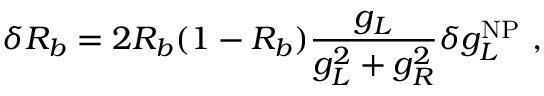<formula> <loc_0><loc_0><loc_500><loc_500>\delta R _ { b } = 2 R _ { b } ( 1 - R _ { b } ) \frac { g _ { L } } { g _ { L } ^ { 2 } + g _ { R } ^ { 2 } } \delta g _ { L } ^ { N P } ,</formula> 